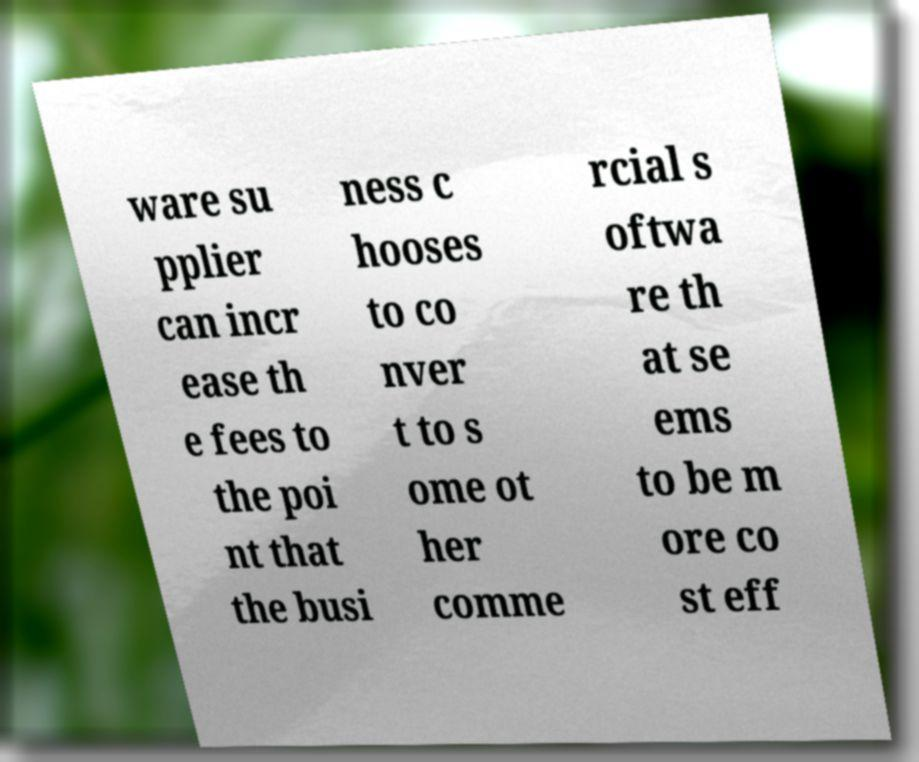Can you read and provide the text displayed in the image?This photo seems to have some interesting text. Can you extract and type it out for me? ware su pplier can incr ease th e fees to the poi nt that the busi ness c hooses to co nver t to s ome ot her comme rcial s oftwa re th at se ems to be m ore co st eff 